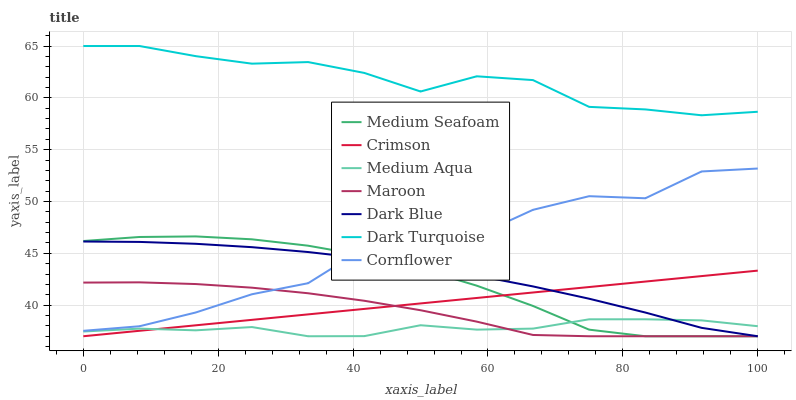Does Maroon have the minimum area under the curve?
Answer yes or no. No. Does Maroon have the maximum area under the curve?
Answer yes or no. No. Is Dark Turquoise the smoothest?
Answer yes or no. No. Is Dark Turquoise the roughest?
Answer yes or no. No. Does Dark Turquoise have the lowest value?
Answer yes or no. No. Does Maroon have the highest value?
Answer yes or no. No. Is Medium Seafoam less than Dark Turquoise?
Answer yes or no. Yes. Is Dark Turquoise greater than Medium Seafoam?
Answer yes or no. Yes. Does Medium Seafoam intersect Dark Turquoise?
Answer yes or no. No. 